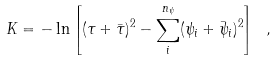<formula> <loc_0><loc_0><loc_500><loc_500>K = - \ln \left [ ( \tau + \bar { \tau } ) ^ { 2 } - \sum _ { i } ^ { n _ { \psi } } ( \psi _ { i } + \bar { \psi } _ { i } ) ^ { 2 } \right ] \ ,</formula> 